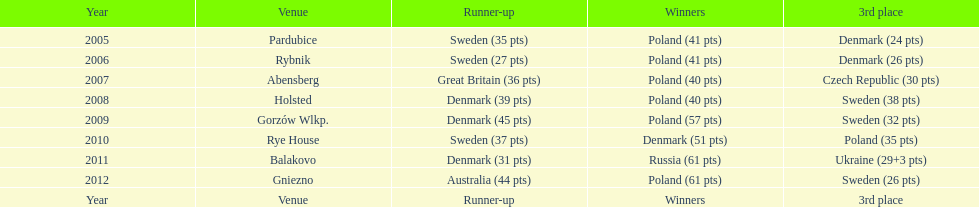Previous to 2008 how many times was sweden the runner up? 2. 